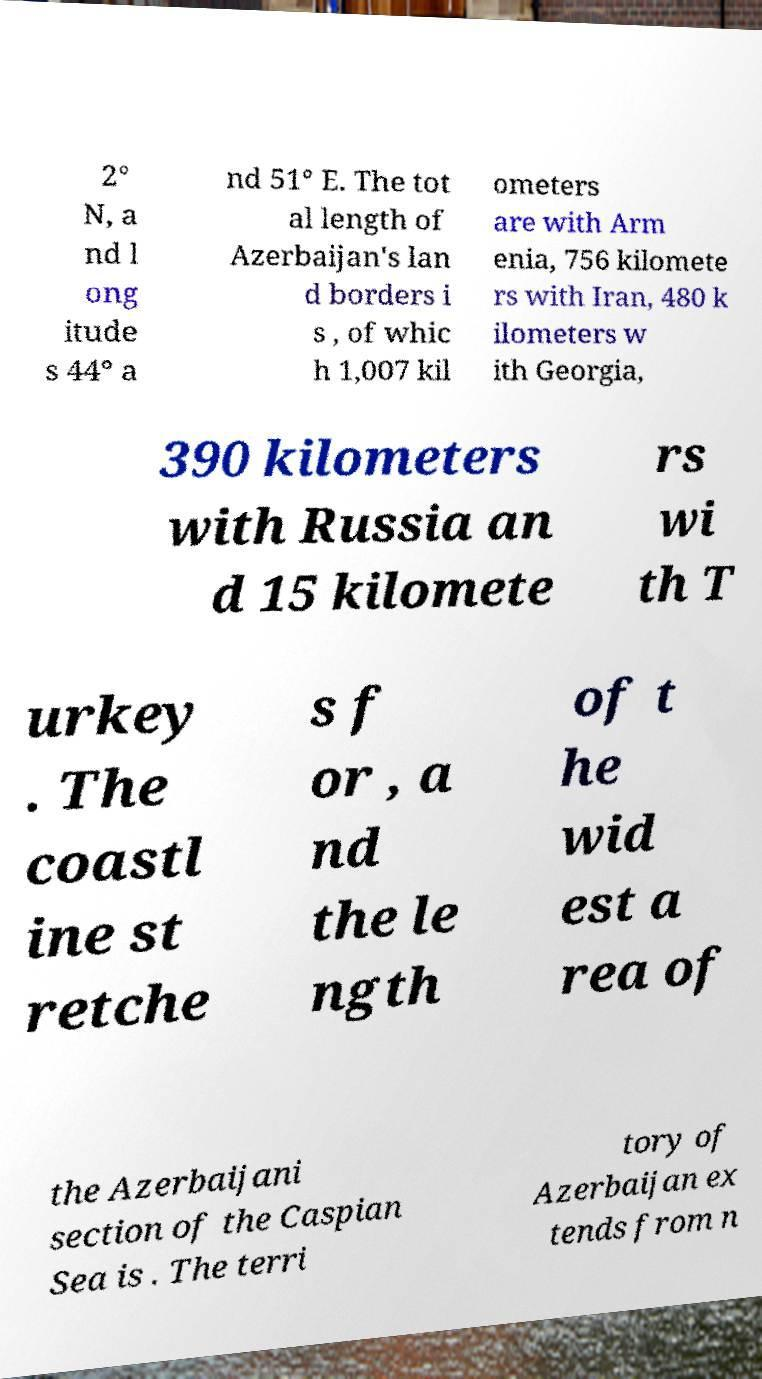Please read and relay the text visible in this image. What does it say? 2° N, a nd l ong itude s 44° a nd 51° E. The tot al length of Azerbaijan's lan d borders i s , of whic h 1,007 kil ometers are with Arm enia, 756 kilomete rs with Iran, 480 k ilometers w ith Georgia, 390 kilometers with Russia an d 15 kilomete rs wi th T urkey . The coastl ine st retche s f or , a nd the le ngth of t he wid est a rea of the Azerbaijani section of the Caspian Sea is . The terri tory of Azerbaijan ex tends from n 